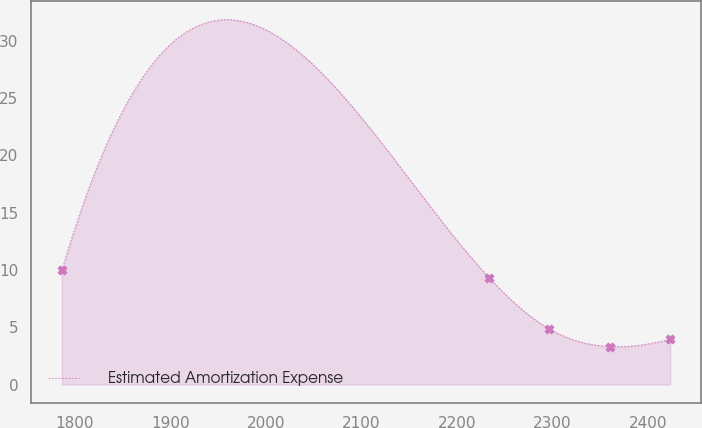<chart> <loc_0><loc_0><loc_500><loc_500><line_chart><ecel><fcel>Estimated Amortization Expense<nl><fcel>1786.7<fcel>9.96<nl><fcel>2233.53<fcel>9.33<nl><fcel>2296.73<fcel>4.85<nl><fcel>2359.93<fcel>3.32<nl><fcel>2423.13<fcel>3.95<nl></chart> 